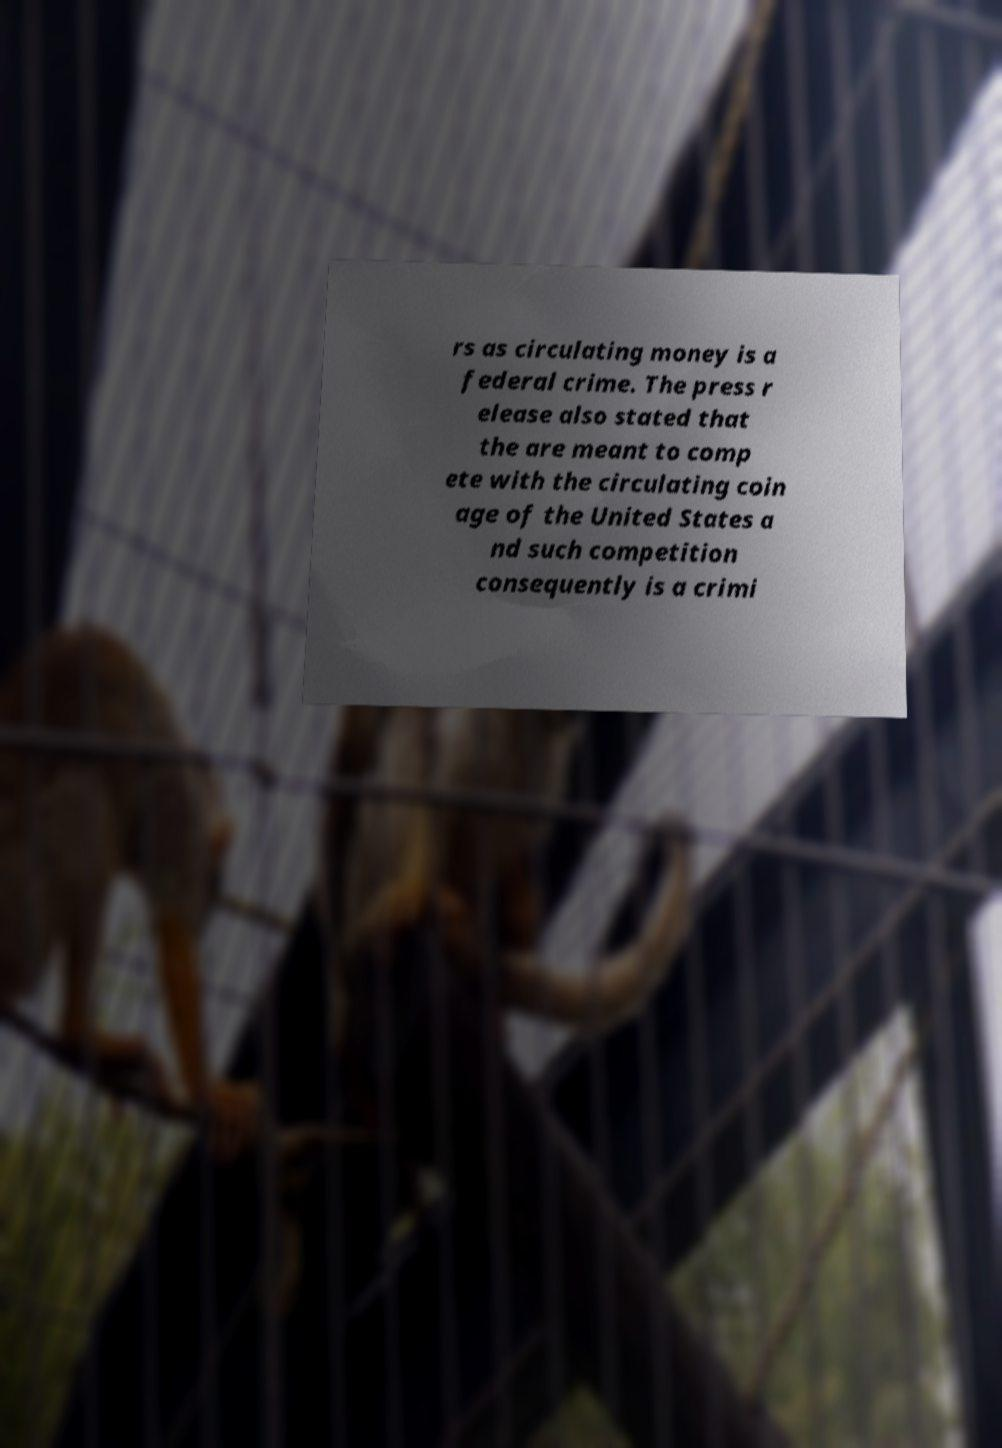For documentation purposes, I need the text within this image transcribed. Could you provide that? rs as circulating money is a federal crime. The press r elease also stated that the are meant to comp ete with the circulating coin age of the United States a nd such competition consequently is a crimi 